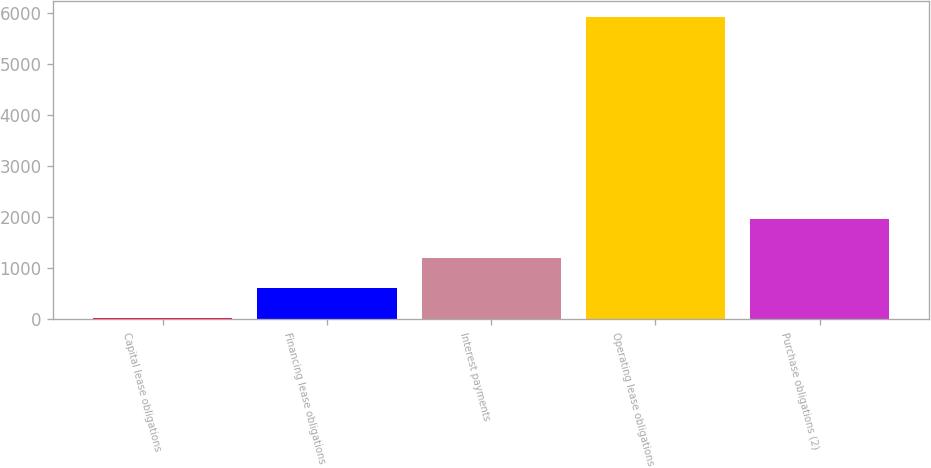<chart> <loc_0><loc_0><loc_500><loc_500><bar_chart><fcel>Capital lease obligations<fcel>Financing lease obligations<fcel>Interest payments<fcel>Operating lease obligations<fcel>Purchase obligations (2)<nl><fcel>27<fcel>617.1<fcel>1207.2<fcel>5928<fcel>1968<nl></chart> 